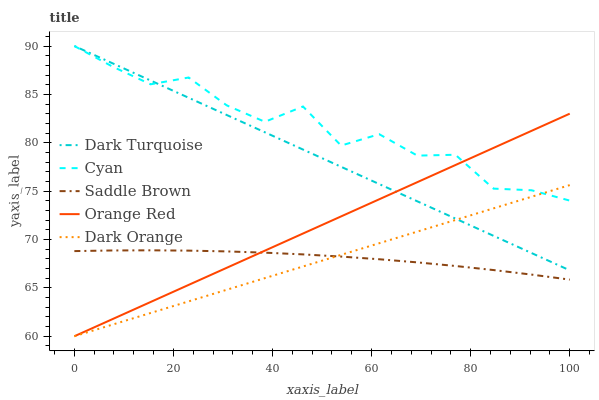Does Dark Orange have the minimum area under the curve?
Answer yes or no. Yes. Does Cyan have the maximum area under the curve?
Answer yes or no. Yes. Does Dark Turquoise have the minimum area under the curve?
Answer yes or no. No. Does Dark Turquoise have the maximum area under the curve?
Answer yes or no. No. Is Orange Red the smoothest?
Answer yes or no. Yes. Is Cyan the roughest?
Answer yes or no. Yes. Is Dark Turquoise the smoothest?
Answer yes or no. No. Is Dark Turquoise the roughest?
Answer yes or no. No. Does Dark Orange have the lowest value?
Answer yes or no. Yes. Does Dark Turquoise have the lowest value?
Answer yes or no. No. Does Cyan have the highest value?
Answer yes or no. Yes. Does Saddle Brown have the highest value?
Answer yes or no. No. Is Saddle Brown less than Cyan?
Answer yes or no. Yes. Is Dark Turquoise greater than Saddle Brown?
Answer yes or no. Yes. Does Cyan intersect Dark Turquoise?
Answer yes or no. Yes. Is Cyan less than Dark Turquoise?
Answer yes or no. No. Is Cyan greater than Dark Turquoise?
Answer yes or no. No. Does Saddle Brown intersect Cyan?
Answer yes or no. No. 